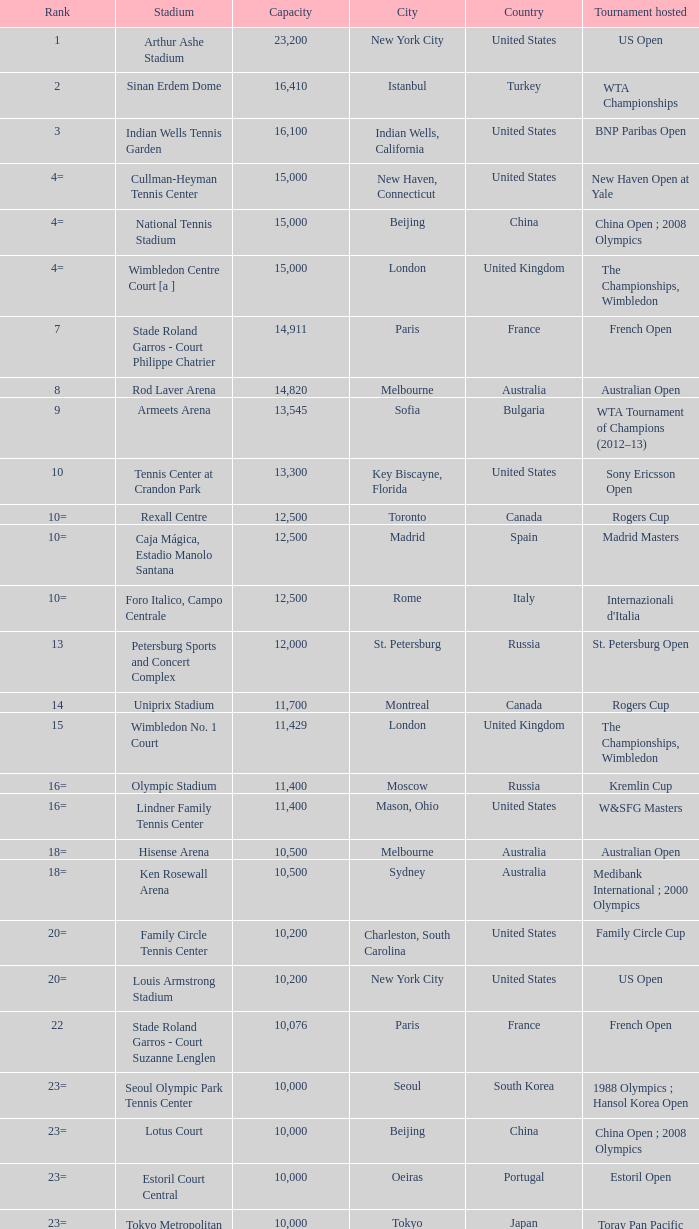What is the typical capacity of rod laver arena as a stadium? 14820.0. 